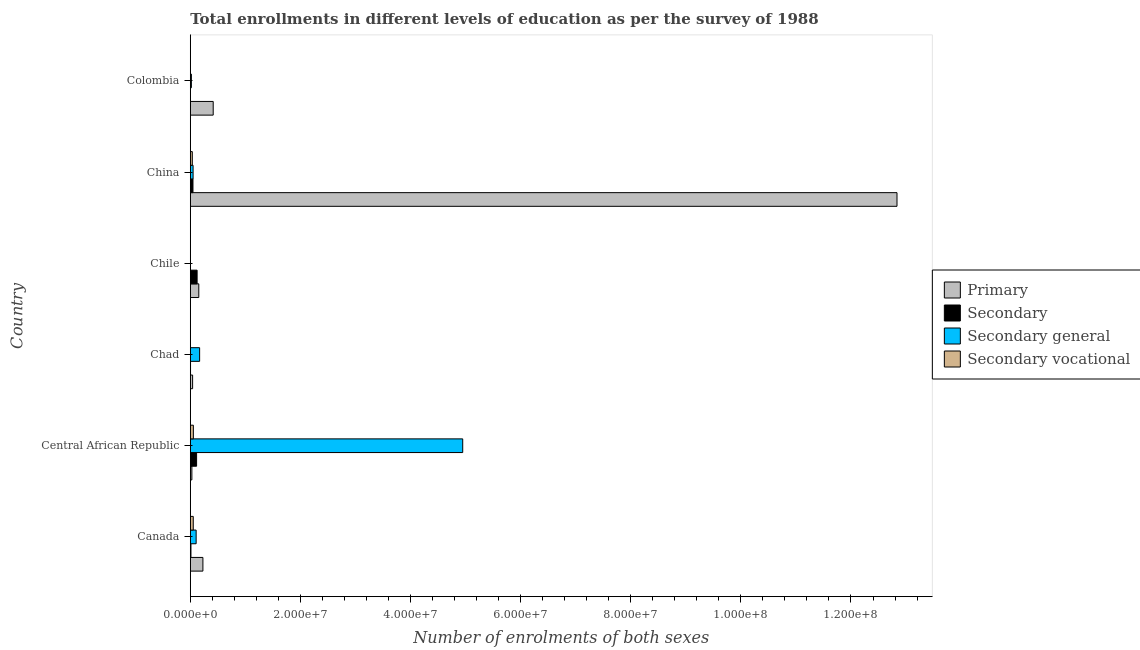How many different coloured bars are there?
Your answer should be compact. 4. How many groups of bars are there?
Give a very brief answer. 6. Are the number of bars per tick equal to the number of legend labels?
Your response must be concise. Yes. Are the number of bars on each tick of the Y-axis equal?
Your answer should be compact. Yes. How many bars are there on the 5th tick from the bottom?
Give a very brief answer. 4. What is the label of the 5th group of bars from the top?
Provide a short and direct response. Central African Republic. What is the number of enrolments in secondary vocational education in Chile?
Offer a very short reply. 2.70e+04. Across all countries, what is the maximum number of enrolments in secondary vocational education?
Make the answer very short. 5.58e+05. Across all countries, what is the minimum number of enrolments in secondary vocational education?
Provide a succinct answer. 3482. In which country was the number of enrolments in primary education maximum?
Offer a very short reply. China. What is the total number of enrolments in secondary education in the graph?
Offer a terse response. 3.04e+06. What is the difference between the number of enrolments in secondary education in Central African Republic and that in Colombia?
Provide a succinct answer. 1.14e+06. What is the difference between the number of enrolments in primary education in Central African Republic and the number of enrolments in secondary general education in Colombia?
Provide a short and direct response. 8.74e+04. What is the average number of enrolments in primary education per country?
Your answer should be very brief. 2.28e+07. What is the difference between the number of enrolments in secondary education and number of enrolments in primary education in Chile?
Give a very brief answer. -3.06e+05. In how many countries, is the number of enrolments in secondary vocational education greater than 4000000 ?
Offer a very short reply. 0. What is the ratio of the number of enrolments in primary education in Canada to that in Chad?
Keep it short and to the point. 5.46. What is the difference between the highest and the second highest number of enrolments in secondary education?
Offer a very short reply. 9.47e+04. What is the difference between the highest and the lowest number of enrolments in primary education?
Your answer should be very brief. 1.28e+08. Is it the case that in every country, the sum of the number of enrolments in primary education and number of enrolments in secondary general education is greater than the sum of number of enrolments in secondary education and number of enrolments in secondary vocational education?
Ensure brevity in your answer.  Yes. What does the 1st bar from the top in Colombia represents?
Give a very brief answer. Secondary vocational. What does the 4th bar from the bottom in China represents?
Give a very brief answer. Secondary vocational. Is it the case that in every country, the sum of the number of enrolments in primary education and number of enrolments in secondary education is greater than the number of enrolments in secondary general education?
Keep it short and to the point. No. How many bars are there?
Provide a succinct answer. 24. How many countries are there in the graph?
Ensure brevity in your answer.  6. What is the difference between two consecutive major ticks on the X-axis?
Your answer should be compact. 2.00e+07. Are the values on the major ticks of X-axis written in scientific E-notation?
Give a very brief answer. Yes. Does the graph contain any zero values?
Keep it short and to the point. No. Does the graph contain grids?
Your response must be concise. No. How are the legend labels stacked?
Make the answer very short. Vertical. What is the title of the graph?
Give a very brief answer. Total enrollments in different levels of education as per the survey of 1988. What is the label or title of the X-axis?
Your answer should be very brief. Number of enrolments of both sexes. What is the label or title of the Y-axis?
Your answer should be very brief. Country. What is the Number of enrolments of both sexes of Primary in Canada?
Give a very brief answer. 2.29e+06. What is the Number of enrolments of both sexes of Secondary in Canada?
Give a very brief answer. 1.18e+05. What is the Number of enrolments of both sexes in Secondary general in Canada?
Keep it short and to the point. 1.06e+06. What is the Number of enrolments of both sexes of Secondary vocational in Canada?
Your answer should be compact. 5.39e+05. What is the Number of enrolments of both sexes in Primary in Central African Republic?
Your response must be concise. 2.86e+05. What is the Number of enrolments of both sexes of Secondary in Central African Republic?
Your answer should be very brief. 1.14e+06. What is the Number of enrolments of both sexes of Secondary general in Central African Republic?
Offer a very short reply. 4.95e+07. What is the Number of enrolments of both sexes in Secondary vocational in Central African Republic?
Offer a very short reply. 5.58e+05. What is the Number of enrolments of both sexes of Primary in Chad?
Provide a short and direct response. 4.19e+05. What is the Number of enrolments of both sexes of Secondary in Chad?
Give a very brief answer. 4.22e+04. What is the Number of enrolments of both sexes in Secondary general in Chad?
Your answer should be compact. 1.70e+06. What is the Number of enrolments of both sexes of Secondary vocational in Chad?
Provide a succinct answer. 2.80e+04. What is the Number of enrolments of both sexes in Primary in Chile?
Give a very brief answer. 1.54e+06. What is the Number of enrolments of both sexes of Secondary in Chile?
Keep it short and to the point. 1.24e+06. What is the Number of enrolments of both sexes in Secondary general in Chile?
Offer a very short reply. 1.92e+04. What is the Number of enrolments of both sexes in Secondary vocational in Chile?
Keep it short and to the point. 2.70e+04. What is the Number of enrolments of both sexes in Primary in China?
Give a very brief answer. 1.28e+08. What is the Number of enrolments of both sexes in Secondary in China?
Keep it short and to the point. 4.86e+05. What is the Number of enrolments of both sexes of Secondary general in China?
Your answer should be compact. 5.08e+05. What is the Number of enrolments of both sexes of Secondary vocational in China?
Your answer should be very brief. 3.68e+05. What is the Number of enrolments of both sexes in Primary in Colombia?
Your answer should be compact. 4.16e+06. What is the Number of enrolments of both sexes of Secondary in Colombia?
Ensure brevity in your answer.  8136. What is the Number of enrolments of both sexes in Secondary general in Colombia?
Keep it short and to the point. 1.99e+05. What is the Number of enrolments of both sexes of Secondary vocational in Colombia?
Your response must be concise. 3482. Across all countries, what is the maximum Number of enrolments of both sexes in Primary?
Your answer should be very brief. 1.28e+08. Across all countries, what is the maximum Number of enrolments of both sexes in Secondary?
Your answer should be compact. 1.24e+06. Across all countries, what is the maximum Number of enrolments of both sexes in Secondary general?
Provide a short and direct response. 4.95e+07. Across all countries, what is the maximum Number of enrolments of both sexes of Secondary vocational?
Offer a very short reply. 5.58e+05. Across all countries, what is the minimum Number of enrolments of both sexes of Primary?
Keep it short and to the point. 2.86e+05. Across all countries, what is the minimum Number of enrolments of both sexes in Secondary?
Make the answer very short. 8136. Across all countries, what is the minimum Number of enrolments of both sexes of Secondary general?
Keep it short and to the point. 1.92e+04. Across all countries, what is the minimum Number of enrolments of both sexes in Secondary vocational?
Provide a short and direct response. 3482. What is the total Number of enrolments of both sexes in Primary in the graph?
Keep it short and to the point. 1.37e+08. What is the total Number of enrolments of both sexes in Secondary in the graph?
Your answer should be very brief. 3.04e+06. What is the total Number of enrolments of both sexes in Secondary general in the graph?
Your response must be concise. 5.30e+07. What is the total Number of enrolments of both sexes in Secondary vocational in the graph?
Your answer should be very brief. 1.52e+06. What is the difference between the Number of enrolments of both sexes of Primary in Canada and that in Central African Republic?
Provide a short and direct response. 2.00e+06. What is the difference between the Number of enrolments of both sexes in Secondary in Canada and that in Central African Republic?
Offer a terse response. -1.02e+06. What is the difference between the Number of enrolments of both sexes of Secondary general in Canada and that in Central African Republic?
Give a very brief answer. -4.84e+07. What is the difference between the Number of enrolments of both sexes in Secondary vocational in Canada and that in Central African Republic?
Your answer should be compact. -1.89e+04. What is the difference between the Number of enrolments of both sexes of Primary in Canada and that in Chad?
Give a very brief answer. 1.87e+06. What is the difference between the Number of enrolments of both sexes of Secondary in Canada and that in Chad?
Keep it short and to the point. 7.62e+04. What is the difference between the Number of enrolments of both sexes in Secondary general in Canada and that in Chad?
Give a very brief answer. -6.33e+05. What is the difference between the Number of enrolments of both sexes in Secondary vocational in Canada and that in Chad?
Offer a terse response. 5.12e+05. What is the difference between the Number of enrolments of both sexes in Primary in Canada and that in Chile?
Offer a terse response. 7.47e+05. What is the difference between the Number of enrolments of both sexes of Secondary in Canada and that in Chile?
Keep it short and to the point. -1.12e+06. What is the difference between the Number of enrolments of both sexes of Secondary general in Canada and that in Chile?
Ensure brevity in your answer.  1.04e+06. What is the difference between the Number of enrolments of both sexes in Secondary vocational in Canada and that in Chile?
Your response must be concise. 5.12e+05. What is the difference between the Number of enrolments of both sexes in Primary in Canada and that in China?
Your answer should be very brief. -1.26e+08. What is the difference between the Number of enrolments of both sexes of Secondary in Canada and that in China?
Your response must be concise. -3.67e+05. What is the difference between the Number of enrolments of both sexes of Secondary general in Canada and that in China?
Offer a terse response. 5.55e+05. What is the difference between the Number of enrolments of both sexes in Secondary vocational in Canada and that in China?
Make the answer very short. 1.72e+05. What is the difference between the Number of enrolments of both sexes of Primary in Canada and that in Colombia?
Make the answer very short. -1.87e+06. What is the difference between the Number of enrolments of both sexes of Secondary in Canada and that in Colombia?
Your answer should be very brief. 1.10e+05. What is the difference between the Number of enrolments of both sexes of Secondary general in Canada and that in Colombia?
Provide a short and direct response. 8.64e+05. What is the difference between the Number of enrolments of both sexes in Secondary vocational in Canada and that in Colombia?
Offer a terse response. 5.36e+05. What is the difference between the Number of enrolments of both sexes in Primary in Central African Republic and that in Chad?
Your answer should be very brief. -1.33e+05. What is the difference between the Number of enrolments of both sexes in Secondary in Central African Republic and that in Chad?
Your response must be concise. 1.10e+06. What is the difference between the Number of enrolments of both sexes in Secondary general in Central African Republic and that in Chad?
Your response must be concise. 4.78e+07. What is the difference between the Number of enrolments of both sexes in Secondary vocational in Central African Republic and that in Chad?
Your answer should be compact. 5.30e+05. What is the difference between the Number of enrolments of both sexes in Primary in Central African Republic and that in Chile?
Provide a short and direct response. -1.26e+06. What is the difference between the Number of enrolments of both sexes of Secondary in Central African Republic and that in Chile?
Give a very brief answer. -9.47e+04. What is the difference between the Number of enrolments of both sexes of Secondary general in Central African Republic and that in Chile?
Make the answer very short. 4.95e+07. What is the difference between the Number of enrolments of both sexes of Secondary vocational in Central African Republic and that in Chile?
Offer a terse response. 5.31e+05. What is the difference between the Number of enrolments of both sexes in Primary in Central African Republic and that in China?
Provide a short and direct response. -1.28e+08. What is the difference between the Number of enrolments of both sexes of Secondary in Central African Republic and that in China?
Your answer should be compact. 6.57e+05. What is the difference between the Number of enrolments of both sexes in Secondary general in Central African Republic and that in China?
Keep it short and to the point. 4.90e+07. What is the difference between the Number of enrolments of both sexes in Secondary vocational in Central African Republic and that in China?
Your answer should be compact. 1.91e+05. What is the difference between the Number of enrolments of both sexes in Primary in Central African Republic and that in Colombia?
Keep it short and to the point. -3.87e+06. What is the difference between the Number of enrolments of both sexes of Secondary in Central African Republic and that in Colombia?
Your response must be concise. 1.14e+06. What is the difference between the Number of enrolments of both sexes in Secondary general in Central African Republic and that in Colombia?
Offer a very short reply. 4.93e+07. What is the difference between the Number of enrolments of both sexes in Secondary vocational in Central African Republic and that in Colombia?
Offer a terse response. 5.55e+05. What is the difference between the Number of enrolments of both sexes of Primary in Chad and that in Chile?
Offer a terse response. -1.12e+06. What is the difference between the Number of enrolments of both sexes of Secondary in Chad and that in Chile?
Your answer should be very brief. -1.20e+06. What is the difference between the Number of enrolments of both sexes in Secondary general in Chad and that in Chile?
Ensure brevity in your answer.  1.68e+06. What is the difference between the Number of enrolments of both sexes of Secondary vocational in Chad and that in Chile?
Ensure brevity in your answer.  967. What is the difference between the Number of enrolments of both sexes in Primary in Chad and that in China?
Your answer should be very brief. -1.28e+08. What is the difference between the Number of enrolments of both sexes in Secondary in Chad and that in China?
Offer a terse response. -4.44e+05. What is the difference between the Number of enrolments of both sexes in Secondary general in Chad and that in China?
Give a very brief answer. 1.19e+06. What is the difference between the Number of enrolments of both sexes in Secondary vocational in Chad and that in China?
Offer a terse response. -3.40e+05. What is the difference between the Number of enrolments of both sexes in Primary in Chad and that in Colombia?
Ensure brevity in your answer.  -3.74e+06. What is the difference between the Number of enrolments of both sexes in Secondary in Chad and that in Colombia?
Give a very brief answer. 3.41e+04. What is the difference between the Number of enrolments of both sexes of Secondary general in Chad and that in Colombia?
Your answer should be compact. 1.50e+06. What is the difference between the Number of enrolments of both sexes in Secondary vocational in Chad and that in Colombia?
Offer a terse response. 2.45e+04. What is the difference between the Number of enrolments of both sexes of Primary in Chile and that in China?
Your answer should be very brief. -1.27e+08. What is the difference between the Number of enrolments of both sexes in Secondary in Chile and that in China?
Your answer should be compact. 7.52e+05. What is the difference between the Number of enrolments of both sexes of Secondary general in Chile and that in China?
Provide a succinct answer. -4.89e+05. What is the difference between the Number of enrolments of both sexes of Secondary vocational in Chile and that in China?
Your response must be concise. -3.41e+05. What is the difference between the Number of enrolments of both sexes of Primary in Chile and that in Colombia?
Offer a very short reply. -2.62e+06. What is the difference between the Number of enrolments of both sexes of Secondary in Chile and that in Colombia?
Offer a very short reply. 1.23e+06. What is the difference between the Number of enrolments of both sexes in Secondary general in Chile and that in Colombia?
Make the answer very short. -1.80e+05. What is the difference between the Number of enrolments of both sexes in Secondary vocational in Chile and that in Colombia?
Offer a very short reply. 2.35e+04. What is the difference between the Number of enrolments of both sexes in Primary in China and that in Colombia?
Offer a terse response. 1.24e+08. What is the difference between the Number of enrolments of both sexes of Secondary in China and that in Colombia?
Your answer should be very brief. 4.78e+05. What is the difference between the Number of enrolments of both sexes of Secondary general in China and that in Colombia?
Your answer should be compact. 3.09e+05. What is the difference between the Number of enrolments of both sexes in Secondary vocational in China and that in Colombia?
Make the answer very short. 3.64e+05. What is the difference between the Number of enrolments of both sexes of Primary in Canada and the Number of enrolments of both sexes of Secondary in Central African Republic?
Offer a terse response. 1.15e+06. What is the difference between the Number of enrolments of both sexes in Primary in Canada and the Number of enrolments of both sexes in Secondary general in Central African Republic?
Provide a succinct answer. -4.72e+07. What is the difference between the Number of enrolments of both sexes of Primary in Canada and the Number of enrolments of both sexes of Secondary vocational in Central African Republic?
Keep it short and to the point. 1.73e+06. What is the difference between the Number of enrolments of both sexes of Secondary in Canada and the Number of enrolments of both sexes of Secondary general in Central African Republic?
Give a very brief answer. -4.94e+07. What is the difference between the Number of enrolments of both sexes in Secondary in Canada and the Number of enrolments of both sexes in Secondary vocational in Central African Republic?
Your response must be concise. -4.40e+05. What is the difference between the Number of enrolments of both sexes of Secondary general in Canada and the Number of enrolments of both sexes of Secondary vocational in Central African Republic?
Offer a very short reply. 5.04e+05. What is the difference between the Number of enrolments of both sexes of Primary in Canada and the Number of enrolments of both sexes of Secondary in Chad?
Offer a terse response. 2.25e+06. What is the difference between the Number of enrolments of both sexes of Primary in Canada and the Number of enrolments of both sexes of Secondary general in Chad?
Offer a terse response. 5.95e+05. What is the difference between the Number of enrolments of both sexes of Primary in Canada and the Number of enrolments of both sexes of Secondary vocational in Chad?
Offer a very short reply. 2.26e+06. What is the difference between the Number of enrolments of both sexes of Secondary in Canada and the Number of enrolments of both sexes of Secondary general in Chad?
Give a very brief answer. -1.58e+06. What is the difference between the Number of enrolments of both sexes of Secondary in Canada and the Number of enrolments of both sexes of Secondary vocational in Chad?
Provide a succinct answer. 9.04e+04. What is the difference between the Number of enrolments of both sexes of Secondary general in Canada and the Number of enrolments of both sexes of Secondary vocational in Chad?
Your answer should be compact. 1.03e+06. What is the difference between the Number of enrolments of both sexes of Primary in Canada and the Number of enrolments of both sexes of Secondary in Chile?
Give a very brief answer. 1.05e+06. What is the difference between the Number of enrolments of both sexes in Primary in Canada and the Number of enrolments of both sexes in Secondary general in Chile?
Your answer should be very brief. 2.27e+06. What is the difference between the Number of enrolments of both sexes in Primary in Canada and the Number of enrolments of both sexes in Secondary vocational in Chile?
Offer a very short reply. 2.26e+06. What is the difference between the Number of enrolments of both sexes of Secondary in Canada and the Number of enrolments of both sexes of Secondary general in Chile?
Provide a short and direct response. 9.91e+04. What is the difference between the Number of enrolments of both sexes of Secondary in Canada and the Number of enrolments of both sexes of Secondary vocational in Chile?
Your answer should be very brief. 9.14e+04. What is the difference between the Number of enrolments of both sexes in Secondary general in Canada and the Number of enrolments of both sexes in Secondary vocational in Chile?
Provide a short and direct response. 1.04e+06. What is the difference between the Number of enrolments of both sexes of Primary in Canada and the Number of enrolments of both sexes of Secondary in China?
Provide a short and direct response. 1.80e+06. What is the difference between the Number of enrolments of both sexes in Primary in Canada and the Number of enrolments of both sexes in Secondary general in China?
Ensure brevity in your answer.  1.78e+06. What is the difference between the Number of enrolments of both sexes of Primary in Canada and the Number of enrolments of both sexes of Secondary vocational in China?
Keep it short and to the point. 1.92e+06. What is the difference between the Number of enrolments of both sexes in Secondary in Canada and the Number of enrolments of both sexes in Secondary general in China?
Ensure brevity in your answer.  -3.90e+05. What is the difference between the Number of enrolments of both sexes in Secondary in Canada and the Number of enrolments of both sexes in Secondary vocational in China?
Keep it short and to the point. -2.49e+05. What is the difference between the Number of enrolments of both sexes of Secondary general in Canada and the Number of enrolments of both sexes of Secondary vocational in China?
Your answer should be compact. 6.95e+05. What is the difference between the Number of enrolments of both sexes in Primary in Canada and the Number of enrolments of both sexes in Secondary in Colombia?
Ensure brevity in your answer.  2.28e+06. What is the difference between the Number of enrolments of both sexes in Primary in Canada and the Number of enrolments of both sexes in Secondary general in Colombia?
Offer a terse response. 2.09e+06. What is the difference between the Number of enrolments of both sexes in Primary in Canada and the Number of enrolments of both sexes in Secondary vocational in Colombia?
Your answer should be compact. 2.29e+06. What is the difference between the Number of enrolments of both sexes in Secondary in Canada and the Number of enrolments of both sexes in Secondary general in Colombia?
Your response must be concise. -8.06e+04. What is the difference between the Number of enrolments of both sexes of Secondary in Canada and the Number of enrolments of both sexes of Secondary vocational in Colombia?
Provide a succinct answer. 1.15e+05. What is the difference between the Number of enrolments of both sexes of Secondary general in Canada and the Number of enrolments of both sexes of Secondary vocational in Colombia?
Offer a terse response. 1.06e+06. What is the difference between the Number of enrolments of both sexes of Primary in Central African Republic and the Number of enrolments of both sexes of Secondary in Chad?
Offer a very short reply. 2.44e+05. What is the difference between the Number of enrolments of both sexes in Primary in Central African Republic and the Number of enrolments of both sexes in Secondary general in Chad?
Provide a short and direct response. -1.41e+06. What is the difference between the Number of enrolments of both sexes in Primary in Central African Republic and the Number of enrolments of both sexes in Secondary vocational in Chad?
Ensure brevity in your answer.  2.58e+05. What is the difference between the Number of enrolments of both sexes of Secondary in Central African Republic and the Number of enrolments of both sexes of Secondary general in Chad?
Ensure brevity in your answer.  -5.53e+05. What is the difference between the Number of enrolments of both sexes in Secondary in Central African Republic and the Number of enrolments of both sexes in Secondary vocational in Chad?
Offer a terse response. 1.12e+06. What is the difference between the Number of enrolments of both sexes in Secondary general in Central African Republic and the Number of enrolments of both sexes in Secondary vocational in Chad?
Your answer should be very brief. 4.95e+07. What is the difference between the Number of enrolments of both sexes in Primary in Central African Republic and the Number of enrolments of both sexes in Secondary in Chile?
Provide a succinct answer. -9.51e+05. What is the difference between the Number of enrolments of both sexes of Primary in Central African Republic and the Number of enrolments of both sexes of Secondary general in Chile?
Offer a terse response. 2.67e+05. What is the difference between the Number of enrolments of both sexes of Primary in Central African Republic and the Number of enrolments of both sexes of Secondary vocational in Chile?
Give a very brief answer. 2.59e+05. What is the difference between the Number of enrolments of both sexes of Secondary in Central African Republic and the Number of enrolments of both sexes of Secondary general in Chile?
Offer a terse response. 1.12e+06. What is the difference between the Number of enrolments of both sexes of Secondary in Central African Republic and the Number of enrolments of both sexes of Secondary vocational in Chile?
Your response must be concise. 1.12e+06. What is the difference between the Number of enrolments of both sexes of Secondary general in Central African Republic and the Number of enrolments of both sexes of Secondary vocational in Chile?
Keep it short and to the point. 4.95e+07. What is the difference between the Number of enrolments of both sexes in Primary in Central African Republic and the Number of enrolments of both sexes in Secondary in China?
Give a very brief answer. -1.99e+05. What is the difference between the Number of enrolments of both sexes in Primary in Central African Republic and the Number of enrolments of both sexes in Secondary general in China?
Provide a short and direct response. -2.22e+05. What is the difference between the Number of enrolments of both sexes in Primary in Central African Republic and the Number of enrolments of both sexes in Secondary vocational in China?
Keep it short and to the point. -8.14e+04. What is the difference between the Number of enrolments of both sexes in Secondary in Central African Republic and the Number of enrolments of both sexes in Secondary general in China?
Offer a very short reply. 6.35e+05. What is the difference between the Number of enrolments of both sexes in Secondary in Central African Republic and the Number of enrolments of both sexes in Secondary vocational in China?
Keep it short and to the point. 7.75e+05. What is the difference between the Number of enrolments of both sexes in Secondary general in Central African Republic and the Number of enrolments of both sexes in Secondary vocational in China?
Provide a short and direct response. 4.91e+07. What is the difference between the Number of enrolments of both sexes in Primary in Central African Republic and the Number of enrolments of both sexes in Secondary in Colombia?
Your response must be concise. 2.78e+05. What is the difference between the Number of enrolments of both sexes of Primary in Central African Republic and the Number of enrolments of both sexes of Secondary general in Colombia?
Give a very brief answer. 8.74e+04. What is the difference between the Number of enrolments of both sexes in Primary in Central African Republic and the Number of enrolments of both sexes in Secondary vocational in Colombia?
Ensure brevity in your answer.  2.83e+05. What is the difference between the Number of enrolments of both sexes in Secondary in Central African Republic and the Number of enrolments of both sexes in Secondary general in Colombia?
Make the answer very short. 9.44e+05. What is the difference between the Number of enrolments of both sexes of Secondary in Central African Republic and the Number of enrolments of both sexes of Secondary vocational in Colombia?
Make the answer very short. 1.14e+06. What is the difference between the Number of enrolments of both sexes of Secondary general in Central African Republic and the Number of enrolments of both sexes of Secondary vocational in Colombia?
Your answer should be very brief. 4.95e+07. What is the difference between the Number of enrolments of both sexes in Primary in Chad and the Number of enrolments of both sexes in Secondary in Chile?
Provide a short and direct response. -8.18e+05. What is the difference between the Number of enrolments of both sexes in Primary in Chad and the Number of enrolments of both sexes in Secondary general in Chile?
Ensure brevity in your answer.  4.00e+05. What is the difference between the Number of enrolments of both sexes of Primary in Chad and the Number of enrolments of both sexes of Secondary vocational in Chile?
Keep it short and to the point. 3.92e+05. What is the difference between the Number of enrolments of both sexes of Secondary in Chad and the Number of enrolments of both sexes of Secondary general in Chile?
Provide a short and direct response. 2.30e+04. What is the difference between the Number of enrolments of both sexes in Secondary in Chad and the Number of enrolments of both sexes in Secondary vocational in Chile?
Your answer should be very brief. 1.52e+04. What is the difference between the Number of enrolments of both sexes in Secondary general in Chad and the Number of enrolments of both sexes in Secondary vocational in Chile?
Offer a terse response. 1.67e+06. What is the difference between the Number of enrolments of both sexes in Primary in Chad and the Number of enrolments of both sexes in Secondary in China?
Your response must be concise. -6.64e+04. What is the difference between the Number of enrolments of both sexes in Primary in Chad and the Number of enrolments of both sexes in Secondary general in China?
Your answer should be compact. -8.85e+04. What is the difference between the Number of enrolments of both sexes in Primary in Chad and the Number of enrolments of both sexes in Secondary vocational in China?
Your response must be concise. 5.16e+04. What is the difference between the Number of enrolments of both sexes of Secondary in Chad and the Number of enrolments of both sexes of Secondary general in China?
Offer a very short reply. -4.66e+05. What is the difference between the Number of enrolments of both sexes of Secondary in Chad and the Number of enrolments of both sexes of Secondary vocational in China?
Keep it short and to the point. -3.26e+05. What is the difference between the Number of enrolments of both sexes of Secondary general in Chad and the Number of enrolments of both sexes of Secondary vocational in China?
Provide a short and direct response. 1.33e+06. What is the difference between the Number of enrolments of both sexes in Primary in Chad and the Number of enrolments of both sexes in Secondary in Colombia?
Your answer should be compact. 4.11e+05. What is the difference between the Number of enrolments of both sexes of Primary in Chad and the Number of enrolments of both sexes of Secondary general in Colombia?
Keep it short and to the point. 2.20e+05. What is the difference between the Number of enrolments of both sexes of Primary in Chad and the Number of enrolments of both sexes of Secondary vocational in Colombia?
Make the answer very short. 4.16e+05. What is the difference between the Number of enrolments of both sexes in Secondary in Chad and the Number of enrolments of both sexes in Secondary general in Colombia?
Offer a very short reply. -1.57e+05. What is the difference between the Number of enrolments of both sexes in Secondary in Chad and the Number of enrolments of both sexes in Secondary vocational in Colombia?
Keep it short and to the point. 3.87e+04. What is the difference between the Number of enrolments of both sexes in Secondary general in Chad and the Number of enrolments of both sexes in Secondary vocational in Colombia?
Give a very brief answer. 1.69e+06. What is the difference between the Number of enrolments of both sexes of Primary in Chile and the Number of enrolments of both sexes of Secondary in China?
Provide a succinct answer. 1.06e+06. What is the difference between the Number of enrolments of both sexes of Primary in Chile and the Number of enrolments of both sexes of Secondary general in China?
Your answer should be compact. 1.04e+06. What is the difference between the Number of enrolments of both sexes in Primary in Chile and the Number of enrolments of both sexes in Secondary vocational in China?
Provide a succinct answer. 1.18e+06. What is the difference between the Number of enrolments of both sexes of Secondary in Chile and the Number of enrolments of both sexes of Secondary general in China?
Ensure brevity in your answer.  7.30e+05. What is the difference between the Number of enrolments of both sexes of Secondary in Chile and the Number of enrolments of both sexes of Secondary vocational in China?
Your answer should be very brief. 8.70e+05. What is the difference between the Number of enrolments of both sexes of Secondary general in Chile and the Number of enrolments of both sexes of Secondary vocational in China?
Give a very brief answer. -3.49e+05. What is the difference between the Number of enrolments of both sexes in Primary in Chile and the Number of enrolments of both sexes in Secondary in Colombia?
Keep it short and to the point. 1.54e+06. What is the difference between the Number of enrolments of both sexes in Primary in Chile and the Number of enrolments of both sexes in Secondary general in Colombia?
Keep it short and to the point. 1.34e+06. What is the difference between the Number of enrolments of both sexes in Primary in Chile and the Number of enrolments of both sexes in Secondary vocational in Colombia?
Give a very brief answer. 1.54e+06. What is the difference between the Number of enrolments of both sexes in Secondary in Chile and the Number of enrolments of both sexes in Secondary general in Colombia?
Provide a succinct answer. 1.04e+06. What is the difference between the Number of enrolments of both sexes of Secondary in Chile and the Number of enrolments of both sexes of Secondary vocational in Colombia?
Offer a very short reply. 1.23e+06. What is the difference between the Number of enrolments of both sexes of Secondary general in Chile and the Number of enrolments of both sexes of Secondary vocational in Colombia?
Offer a very short reply. 1.58e+04. What is the difference between the Number of enrolments of both sexes of Primary in China and the Number of enrolments of both sexes of Secondary in Colombia?
Make the answer very short. 1.28e+08. What is the difference between the Number of enrolments of both sexes of Primary in China and the Number of enrolments of both sexes of Secondary general in Colombia?
Offer a terse response. 1.28e+08. What is the difference between the Number of enrolments of both sexes of Primary in China and the Number of enrolments of both sexes of Secondary vocational in Colombia?
Your answer should be very brief. 1.28e+08. What is the difference between the Number of enrolments of both sexes of Secondary in China and the Number of enrolments of both sexes of Secondary general in Colombia?
Provide a short and direct response. 2.87e+05. What is the difference between the Number of enrolments of both sexes in Secondary in China and the Number of enrolments of both sexes in Secondary vocational in Colombia?
Provide a short and direct response. 4.82e+05. What is the difference between the Number of enrolments of both sexes in Secondary general in China and the Number of enrolments of both sexes in Secondary vocational in Colombia?
Make the answer very short. 5.04e+05. What is the average Number of enrolments of both sexes in Primary per country?
Offer a very short reply. 2.28e+07. What is the average Number of enrolments of both sexes in Secondary per country?
Offer a very short reply. 5.06e+05. What is the average Number of enrolments of both sexes in Secondary general per country?
Offer a terse response. 8.83e+06. What is the average Number of enrolments of both sexes in Secondary vocational per country?
Ensure brevity in your answer.  2.54e+05. What is the difference between the Number of enrolments of both sexes in Primary and Number of enrolments of both sexes in Secondary in Canada?
Make the answer very short. 2.17e+06. What is the difference between the Number of enrolments of both sexes of Primary and Number of enrolments of both sexes of Secondary general in Canada?
Your response must be concise. 1.23e+06. What is the difference between the Number of enrolments of both sexes of Primary and Number of enrolments of both sexes of Secondary vocational in Canada?
Your answer should be compact. 1.75e+06. What is the difference between the Number of enrolments of both sexes of Secondary and Number of enrolments of both sexes of Secondary general in Canada?
Ensure brevity in your answer.  -9.45e+05. What is the difference between the Number of enrolments of both sexes in Secondary and Number of enrolments of both sexes in Secondary vocational in Canada?
Give a very brief answer. -4.21e+05. What is the difference between the Number of enrolments of both sexes of Secondary general and Number of enrolments of both sexes of Secondary vocational in Canada?
Keep it short and to the point. 5.23e+05. What is the difference between the Number of enrolments of both sexes in Primary and Number of enrolments of both sexes in Secondary in Central African Republic?
Offer a terse response. -8.57e+05. What is the difference between the Number of enrolments of both sexes of Primary and Number of enrolments of both sexes of Secondary general in Central African Republic?
Your response must be concise. -4.92e+07. What is the difference between the Number of enrolments of both sexes in Primary and Number of enrolments of both sexes in Secondary vocational in Central African Republic?
Provide a succinct answer. -2.72e+05. What is the difference between the Number of enrolments of both sexes in Secondary and Number of enrolments of both sexes in Secondary general in Central African Republic?
Make the answer very short. -4.83e+07. What is the difference between the Number of enrolments of both sexes of Secondary and Number of enrolments of both sexes of Secondary vocational in Central African Republic?
Your answer should be very brief. 5.85e+05. What is the difference between the Number of enrolments of both sexes of Secondary general and Number of enrolments of both sexes of Secondary vocational in Central African Republic?
Your answer should be very brief. 4.89e+07. What is the difference between the Number of enrolments of both sexes of Primary and Number of enrolments of both sexes of Secondary in Chad?
Give a very brief answer. 3.77e+05. What is the difference between the Number of enrolments of both sexes in Primary and Number of enrolments of both sexes in Secondary general in Chad?
Ensure brevity in your answer.  -1.28e+06. What is the difference between the Number of enrolments of both sexes in Primary and Number of enrolments of both sexes in Secondary vocational in Chad?
Make the answer very short. 3.91e+05. What is the difference between the Number of enrolments of both sexes in Secondary and Number of enrolments of both sexes in Secondary general in Chad?
Keep it short and to the point. -1.65e+06. What is the difference between the Number of enrolments of both sexes in Secondary and Number of enrolments of both sexes in Secondary vocational in Chad?
Keep it short and to the point. 1.42e+04. What is the difference between the Number of enrolments of both sexes of Secondary general and Number of enrolments of both sexes of Secondary vocational in Chad?
Keep it short and to the point. 1.67e+06. What is the difference between the Number of enrolments of both sexes in Primary and Number of enrolments of both sexes in Secondary in Chile?
Provide a short and direct response. 3.06e+05. What is the difference between the Number of enrolments of both sexes of Primary and Number of enrolments of both sexes of Secondary general in Chile?
Keep it short and to the point. 1.52e+06. What is the difference between the Number of enrolments of both sexes of Primary and Number of enrolments of both sexes of Secondary vocational in Chile?
Make the answer very short. 1.52e+06. What is the difference between the Number of enrolments of both sexes of Secondary and Number of enrolments of both sexes of Secondary general in Chile?
Your answer should be very brief. 1.22e+06. What is the difference between the Number of enrolments of both sexes of Secondary and Number of enrolments of both sexes of Secondary vocational in Chile?
Offer a terse response. 1.21e+06. What is the difference between the Number of enrolments of both sexes of Secondary general and Number of enrolments of both sexes of Secondary vocational in Chile?
Your response must be concise. -7762. What is the difference between the Number of enrolments of both sexes in Primary and Number of enrolments of both sexes in Secondary in China?
Ensure brevity in your answer.  1.28e+08. What is the difference between the Number of enrolments of both sexes in Primary and Number of enrolments of both sexes in Secondary general in China?
Ensure brevity in your answer.  1.28e+08. What is the difference between the Number of enrolments of both sexes in Primary and Number of enrolments of both sexes in Secondary vocational in China?
Your response must be concise. 1.28e+08. What is the difference between the Number of enrolments of both sexes in Secondary and Number of enrolments of both sexes in Secondary general in China?
Offer a very short reply. -2.21e+04. What is the difference between the Number of enrolments of both sexes in Secondary and Number of enrolments of both sexes in Secondary vocational in China?
Offer a very short reply. 1.18e+05. What is the difference between the Number of enrolments of both sexes of Secondary general and Number of enrolments of both sexes of Secondary vocational in China?
Your response must be concise. 1.40e+05. What is the difference between the Number of enrolments of both sexes in Primary and Number of enrolments of both sexes in Secondary in Colombia?
Ensure brevity in your answer.  4.15e+06. What is the difference between the Number of enrolments of both sexes of Primary and Number of enrolments of both sexes of Secondary general in Colombia?
Offer a very short reply. 3.96e+06. What is the difference between the Number of enrolments of both sexes of Primary and Number of enrolments of both sexes of Secondary vocational in Colombia?
Offer a very short reply. 4.16e+06. What is the difference between the Number of enrolments of both sexes of Secondary and Number of enrolments of both sexes of Secondary general in Colombia?
Provide a succinct answer. -1.91e+05. What is the difference between the Number of enrolments of both sexes in Secondary and Number of enrolments of both sexes in Secondary vocational in Colombia?
Make the answer very short. 4654. What is the difference between the Number of enrolments of both sexes of Secondary general and Number of enrolments of both sexes of Secondary vocational in Colombia?
Keep it short and to the point. 1.96e+05. What is the ratio of the Number of enrolments of both sexes of Primary in Canada to that in Central African Republic?
Make the answer very short. 8. What is the ratio of the Number of enrolments of both sexes in Secondary in Canada to that in Central African Republic?
Your answer should be very brief. 0.1. What is the ratio of the Number of enrolments of both sexes in Secondary general in Canada to that in Central African Republic?
Keep it short and to the point. 0.02. What is the ratio of the Number of enrolments of both sexes of Secondary vocational in Canada to that in Central African Republic?
Give a very brief answer. 0.97. What is the ratio of the Number of enrolments of both sexes in Primary in Canada to that in Chad?
Ensure brevity in your answer.  5.46. What is the ratio of the Number of enrolments of both sexes of Secondary in Canada to that in Chad?
Your response must be concise. 2.81. What is the ratio of the Number of enrolments of both sexes in Secondary general in Canada to that in Chad?
Your response must be concise. 0.63. What is the ratio of the Number of enrolments of both sexes in Secondary vocational in Canada to that in Chad?
Your answer should be very brief. 19.29. What is the ratio of the Number of enrolments of both sexes in Primary in Canada to that in Chile?
Your answer should be very brief. 1.48. What is the ratio of the Number of enrolments of both sexes in Secondary in Canada to that in Chile?
Your answer should be very brief. 0.1. What is the ratio of the Number of enrolments of both sexes in Secondary general in Canada to that in Chile?
Your answer should be compact. 55.24. What is the ratio of the Number of enrolments of both sexes in Secondary vocational in Canada to that in Chile?
Provide a short and direct response. 19.98. What is the ratio of the Number of enrolments of both sexes in Primary in Canada to that in China?
Keep it short and to the point. 0.02. What is the ratio of the Number of enrolments of both sexes in Secondary in Canada to that in China?
Offer a terse response. 0.24. What is the ratio of the Number of enrolments of both sexes in Secondary general in Canada to that in China?
Your response must be concise. 2.09. What is the ratio of the Number of enrolments of both sexes in Secondary vocational in Canada to that in China?
Give a very brief answer. 1.47. What is the ratio of the Number of enrolments of both sexes of Primary in Canada to that in Colombia?
Give a very brief answer. 0.55. What is the ratio of the Number of enrolments of both sexes in Secondary in Canada to that in Colombia?
Your answer should be compact. 14.55. What is the ratio of the Number of enrolments of both sexes in Secondary general in Canada to that in Colombia?
Offer a very short reply. 5.34. What is the ratio of the Number of enrolments of both sexes of Secondary vocational in Canada to that in Colombia?
Provide a short and direct response. 154.93. What is the ratio of the Number of enrolments of both sexes in Primary in Central African Republic to that in Chad?
Keep it short and to the point. 0.68. What is the ratio of the Number of enrolments of both sexes in Secondary in Central African Republic to that in Chad?
Your answer should be very brief. 27.09. What is the ratio of the Number of enrolments of both sexes of Secondary general in Central African Republic to that in Chad?
Keep it short and to the point. 29.18. What is the ratio of the Number of enrolments of both sexes of Secondary vocational in Central African Republic to that in Chad?
Your answer should be compact. 19.96. What is the ratio of the Number of enrolments of both sexes in Primary in Central African Republic to that in Chile?
Make the answer very short. 0.19. What is the ratio of the Number of enrolments of both sexes in Secondary in Central African Republic to that in Chile?
Your answer should be very brief. 0.92. What is the ratio of the Number of enrolments of both sexes in Secondary general in Central African Republic to that in Chile?
Ensure brevity in your answer.  2571.65. What is the ratio of the Number of enrolments of both sexes of Secondary vocational in Central African Republic to that in Chile?
Your response must be concise. 20.68. What is the ratio of the Number of enrolments of both sexes of Primary in Central African Republic to that in China?
Provide a short and direct response. 0. What is the ratio of the Number of enrolments of both sexes in Secondary in Central African Republic to that in China?
Offer a very short reply. 2.35. What is the ratio of the Number of enrolments of both sexes of Secondary general in Central African Republic to that in China?
Provide a short and direct response. 97.41. What is the ratio of the Number of enrolments of both sexes in Secondary vocational in Central African Republic to that in China?
Keep it short and to the point. 1.52. What is the ratio of the Number of enrolments of both sexes of Primary in Central African Republic to that in Colombia?
Ensure brevity in your answer.  0.07. What is the ratio of the Number of enrolments of both sexes of Secondary in Central African Republic to that in Colombia?
Keep it short and to the point. 140.5. What is the ratio of the Number of enrolments of both sexes in Secondary general in Central African Republic to that in Colombia?
Offer a terse response. 248.67. What is the ratio of the Number of enrolments of both sexes of Secondary vocational in Central African Republic to that in Colombia?
Offer a very short reply. 160.37. What is the ratio of the Number of enrolments of both sexes in Primary in Chad to that in Chile?
Your answer should be compact. 0.27. What is the ratio of the Number of enrolments of both sexes in Secondary in Chad to that in Chile?
Offer a very short reply. 0.03. What is the ratio of the Number of enrolments of both sexes of Secondary general in Chad to that in Chile?
Offer a very short reply. 88.14. What is the ratio of the Number of enrolments of both sexes of Secondary vocational in Chad to that in Chile?
Your answer should be very brief. 1.04. What is the ratio of the Number of enrolments of both sexes in Primary in Chad to that in China?
Make the answer very short. 0. What is the ratio of the Number of enrolments of both sexes of Secondary in Chad to that in China?
Keep it short and to the point. 0.09. What is the ratio of the Number of enrolments of both sexes of Secondary general in Chad to that in China?
Offer a terse response. 3.34. What is the ratio of the Number of enrolments of both sexes in Secondary vocational in Chad to that in China?
Provide a short and direct response. 0.08. What is the ratio of the Number of enrolments of both sexes in Primary in Chad to that in Colombia?
Keep it short and to the point. 0.1. What is the ratio of the Number of enrolments of both sexes of Secondary in Chad to that in Colombia?
Provide a short and direct response. 5.19. What is the ratio of the Number of enrolments of both sexes of Secondary general in Chad to that in Colombia?
Make the answer very short. 8.52. What is the ratio of the Number of enrolments of both sexes in Secondary vocational in Chad to that in Colombia?
Provide a short and direct response. 8.03. What is the ratio of the Number of enrolments of both sexes in Primary in Chile to that in China?
Ensure brevity in your answer.  0.01. What is the ratio of the Number of enrolments of both sexes of Secondary in Chile to that in China?
Make the answer very short. 2.55. What is the ratio of the Number of enrolments of both sexes in Secondary general in Chile to that in China?
Make the answer very short. 0.04. What is the ratio of the Number of enrolments of both sexes of Secondary vocational in Chile to that in China?
Offer a terse response. 0.07. What is the ratio of the Number of enrolments of both sexes of Primary in Chile to that in Colombia?
Give a very brief answer. 0.37. What is the ratio of the Number of enrolments of both sexes in Secondary in Chile to that in Colombia?
Give a very brief answer. 152.14. What is the ratio of the Number of enrolments of both sexes in Secondary general in Chile to that in Colombia?
Offer a very short reply. 0.1. What is the ratio of the Number of enrolments of both sexes in Secondary vocational in Chile to that in Colombia?
Offer a terse response. 7.75. What is the ratio of the Number of enrolments of both sexes in Primary in China to that in Colombia?
Make the answer very short. 30.85. What is the ratio of the Number of enrolments of both sexes of Secondary in China to that in Colombia?
Provide a short and direct response. 59.72. What is the ratio of the Number of enrolments of both sexes in Secondary general in China to that in Colombia?
Keep it short and to the point. 2.55. What is the ratio of the Number of enrolments of both sexes in Secondary vocational in China to that in Colombia?
Keep it short and to the point. 105.63. What is the difference between the highest and the second highest Number of enrolments of both sexes in Primary?
Offer a terse response. 1.24e+08. What is the difference between the highest and the second highest Number of enrolments of both sexes in Secondary?
Your answer should be very brief. 9.47e+04. What is the difference between the highest and the second highest Number of enrolments of both sexes of Secondary general?
Ensure brevity in your answer.  4.78e+07. What is the difference between the highest and the second highest Number of enrolments of both sexes of Secondary vocational?
Provide a short and direct response. 1.89e+04. What is the difference between the highest and the lowest Number of enrolments of both sexes in Primary?
Your response must be concise. 1.28e+08. What is the difference between the highest and the lowest Number of enrolments of both sexes in Secondary?
Make the answer very short. 1.23e+06. What is the difference between the highest and the lowest Number of enrolments of both sexes in Secondary general?
Your answer should be very brief. 4.95e+07. What is the difference between the highest and the lowest Number of enrolments of both sexes of Secondary vocational?
Your response must be concise. 5.55e+05. 